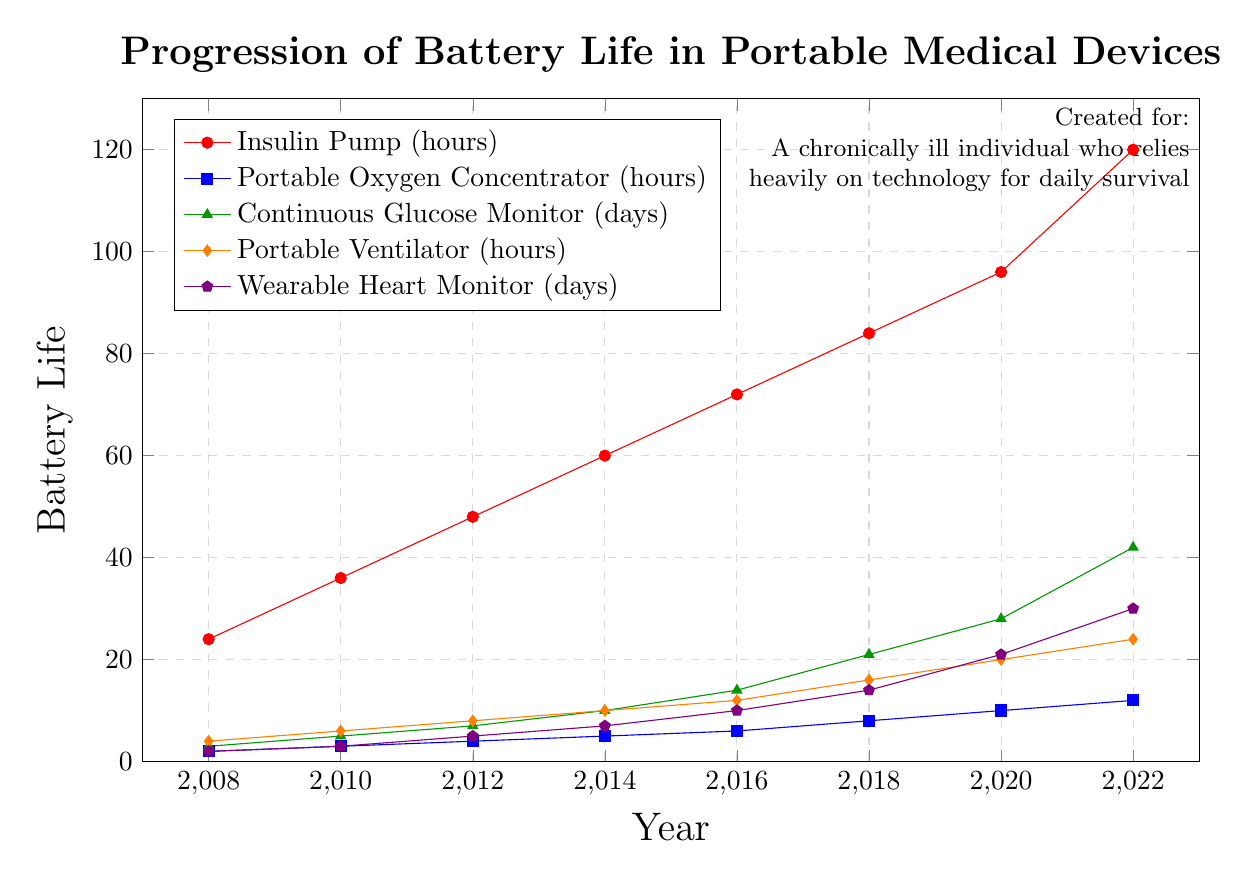What is the battery life of the Insulin Pump in 2016? The plot shows that the Insulin Pump's battery life in 2016 is marked around 72 hours. Simply referring to the point on the Insulin Pump line in the year 2016 gives the value.
Answer: 72 hours Which device had the highest battery life improvement from 2008 to 2022? To determine the highest battery life improvement, calculate the difference between 2008 and 2022 for each device. The Continuous Glucose Monitor increased from 3 days to 42 days, a difference of 39 days. Other devices have smaller improvements.
Answer: Continuous Glucose Monitor How does the battery life of a Portable Ventilator in 2022 compare to an Insulin Pump in 2010? The Portable Ventilator in 2022 has a battery life of 24 hours, and the Insulin Pump in 2010 has a battery life of 36 hours. Comparing these values directly shows that the Insulin Pump's battery life was greater in 2010.
Answer: Insulin Pump in 2010 had a longer battery life What is the average battery life of the Portable Oxygen Concentrator from 2008 to 2022? Sum the battery life values of the Portable Oxygen Concentrator from 2008 to 2022 (2, 3, 4, 5, 6, 8, 10, 12), which equals 50. Divide this sum by the number of years (8) to find the average.
Answer: 6.25 hours Which two devices have the most similar battery life in 2014? Check the battery life values for all devices in 2014: Insulin Pump (60 hours), Portable Oxygen Concentrator (5 hours), Continuous Glucose Monitor (10 days), Portable Ventilator (10 hours), Wearable Heart Monitor (7 days). The Continuous Glucose Monitor and Portable Ventilator both have a battery life close to 10, making them the most similar.
Answer: Continuous Glucose Monitor and Portable Ventilator In which year does the Portable Ventilator's battery life become twice as long as the Insulin Pump's battery life in 2008? The Insulin Pump’s battery life in 2008 is 24 hours. Doubling this value gives 48 hours. The Portable Ventilator line reaches 48 hours in none of the years. Closest values are 2020 (20 hours) and 2022 (24 hours).
Answer: Does not happen What is the increase in battery life for the Wearable Heart Monitor from 2016 to 2020? The battery life of the Wearable Heart Monitor in 2016 is 10 days, and in 2020 it is 21 days. The difference is 21 - 10 = 11 days.
Answer: 11 days How many years did it take for the battery life of the Continuous Glucose Monitor to increase from 3 days to 42 days? The Continuous Glucose Monitor had a battery life of 3 days in 2008 and 42 days in 2022. Subtracting the years gives 2022 - 2008 = 14 years.
Answer: 14 years 